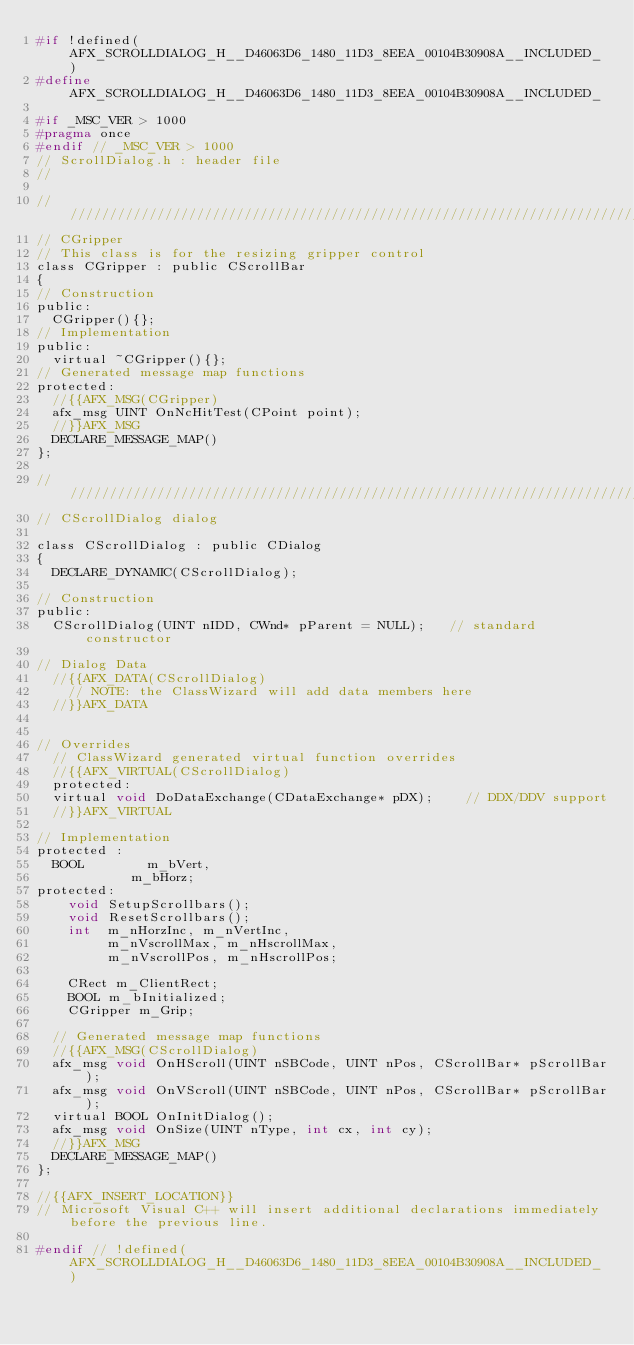<code> <loc_0><loc_0><loc_500><loc_500><_C_>#if !defined(AFX_SCROLLDIALOG_H__D46063D6_1480_11D3_8EEA_00104B30908A__INCLUDED_)
#define AFX_SCROLLDIALOG_H__D46063D6_1480_11D3_8EEA_00104B30908A__INCLUDED_

#if _MSC_VER > 1000
#pragma once
#endif // _MSC_VER > 1000
// ScrollDialog.h : header file
//

/////////////////////////////////////////////////////////////////////////////
// CGripper
// This class is for the resizing gripper control
class CGripper : public CScrollBar
{
// Construction
public:
	CGripper(){};
// Implementation
public:
	virtual ~CGripper(){};
// Generated message map functions
protected:
	//{{AFX_MSG(CGripper)
	afx_msg UINT OnNcHitTest(CPoint point);
	//}}AFX_MSG
	DECLARE_MESSAGE_MAP()
};

/////////////////////////////////////////////////////////////////////////////
// CScrollDialog dialog

class CScrollDialog : public CDialog
{
	DECLARE_DYNAMIC(CScrollDialog);

// Construction
public:
	CScrollDialog(UINT nIDD, CWnd* pParent = NULL);   // standard constructor

// Dialog Data
	//{{AFX_DATA(CScrollDialog)
		// NOTE: the ClassWizard will add data members here
	//}}AFX_DATA


// Overrides
	// ClassWizard generated virtual function overrides
	//{{AFX_VIRTUAL(CScrollDialog)
	protected:
	virtual void DoDataExchange(CDataExchange* pDX);    // DDX/DDV support
	//}}AFX_VIRTUAL

// Implementation
protected :
	BOOL				m_bVert,
						m_bHorz;
protected:
    void SetupScrollbars();
    void ResetScrollbars();
    int  m_nHorzInc, m_nVertInc,
         m_nVscrollMax, m_nHscrollMax,
         m_nVscrollPos, m_nHscrollPos;

    CRect m_ClientRect;
    BOOL m_bInitialized;
    CGripper m_Grip;

	// Generated message map functions
	//{{AFX_MSG(CScrollDialog)
	afx_msg void OnHScroll(UINT nSBCode, UINT nPos, CScrollBar* pScrollBar);
	afx_msg void OnVScroll(UINT nSBCode, UINT nPos, CScrollBar* pScrollBar);
	virtual BOOL OnInitDialog();
	afx_msg void OnSize(UINT nType, int cx, int cy);
	//}}AFX_MSG
	DECLARE_MESSAGE_MAP()
};

//{{AFX_INSERT_LOCATION}}
// Microsoft Visual C++ will insert additional declarations immediately before the previous line.

#endif // !defined(AFX_SCROLLDIALOG_H__D46063D6_1480_11D3_8EEA_00104B30908A__INCLUDED_)
</code> 